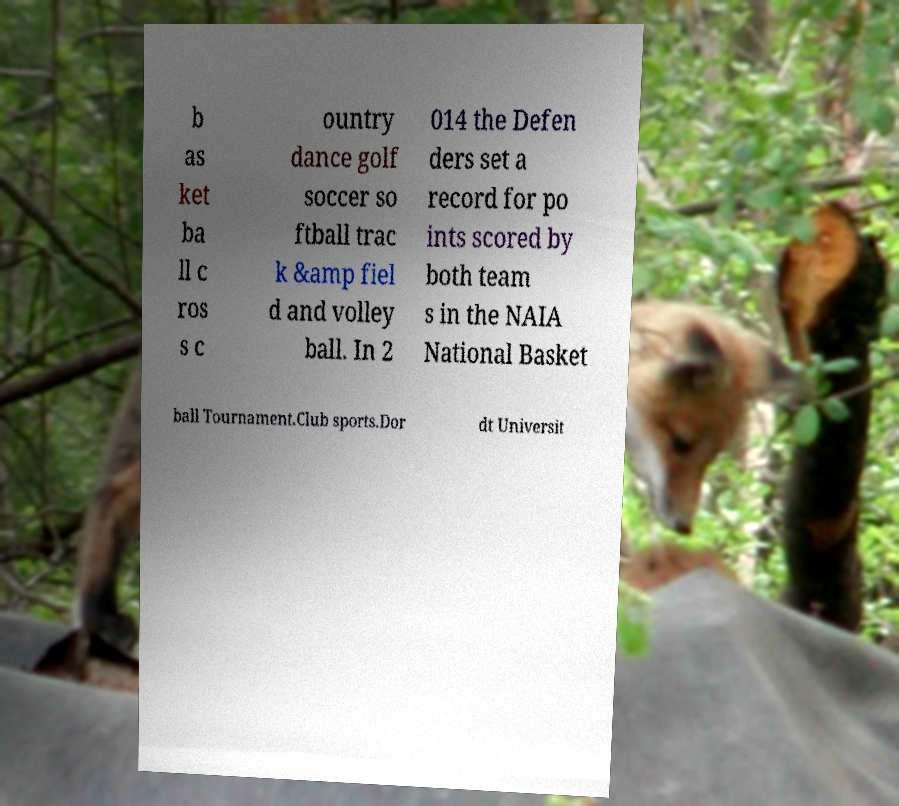Can you read and provide the text displayed in the image?This photo seems to have some interesting text. Can you extract and type it out for me? b as ket ba ll c ros s c ountry dance golf soccer so ftball trac k &amp fiel d and volley ball. In 2 014 the Defen ders set a record for po ints scored by both team s in the NAIA National Basket ball Tournament.Club sports.Dor dt Universit 